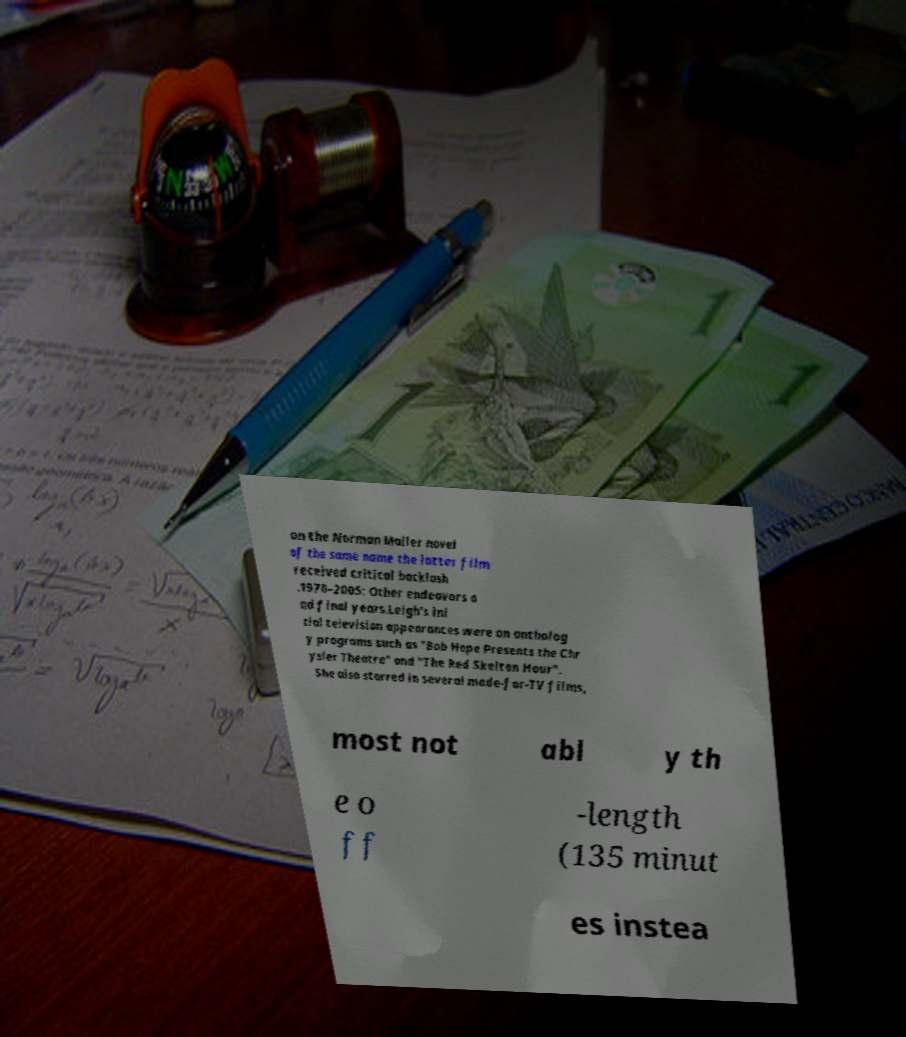Can you accurately transcribe the text from the provided image for me? on the Norman Mailer novel of the same name the latter film received critical backlash .1970–2005: Other endeavors a nd final years.Leigh's ini tial television appearances were on antholog y programs such as "Bob Hope Presents the Chr ysler Theatre" and "The Red Skelton Hour". She also starred in several made-for-TV films, most not abl y th e o ff -length (135 minut es instea 